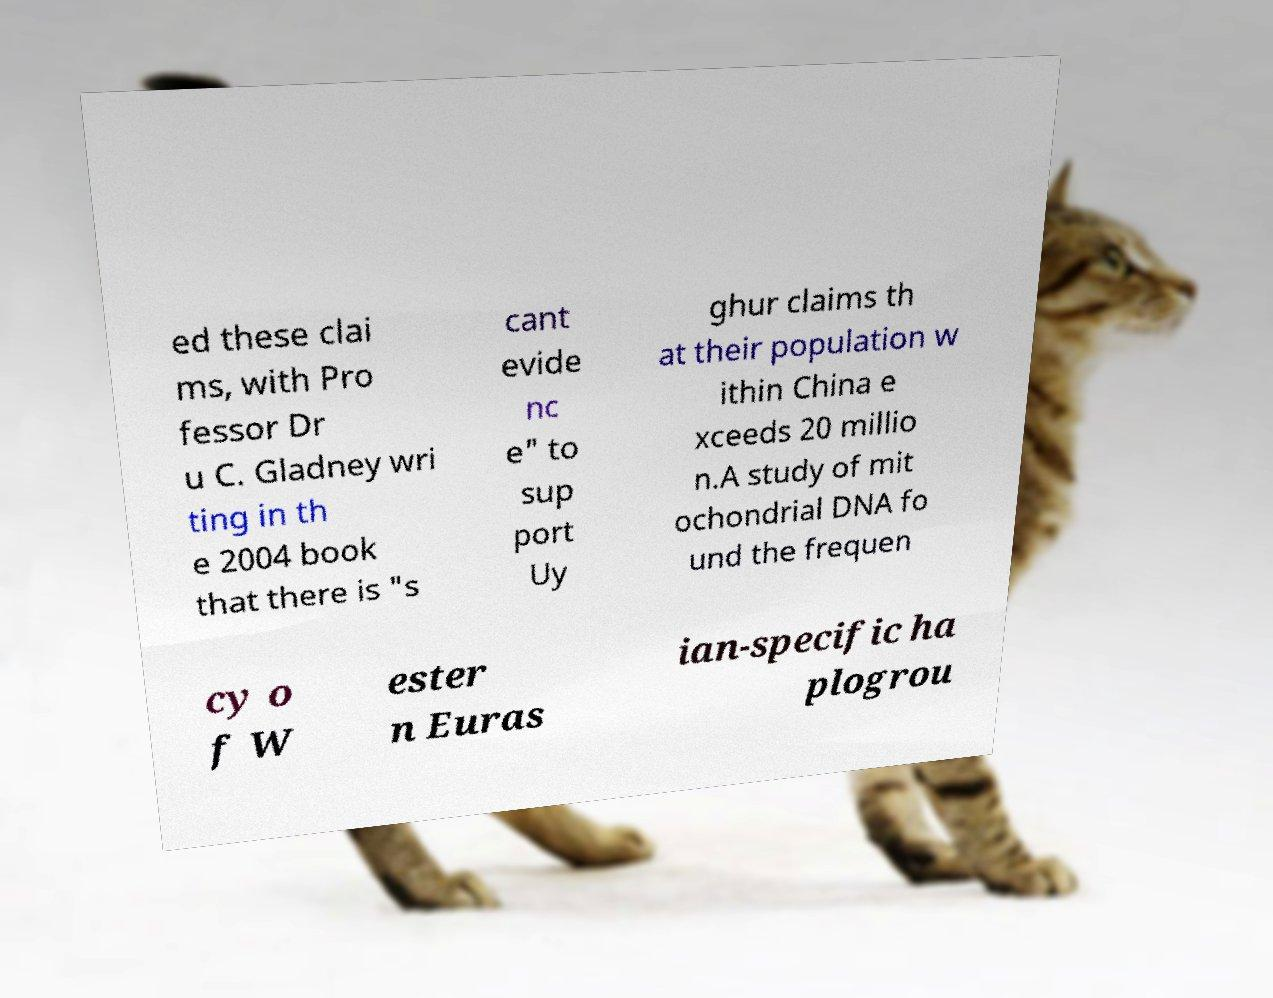There's text embedded in this image that I need extracted. Can you transcribe it verbatim? ed these clai ms, with Pro fessor Dr u C. Gladney wri ting in th e 2004 book that there is "s cant evide nc e" to sup port Uy ghur claims th at their population w ithin China e xceeds 20 millio n.A study of mit ochondrial DNA fo und the frequen cy o f W ester n Euras ian-specific ha plogrou 